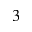<formula> <loc_0><loc_0><loc_500><loc_500>^ { 3 }</formula> 